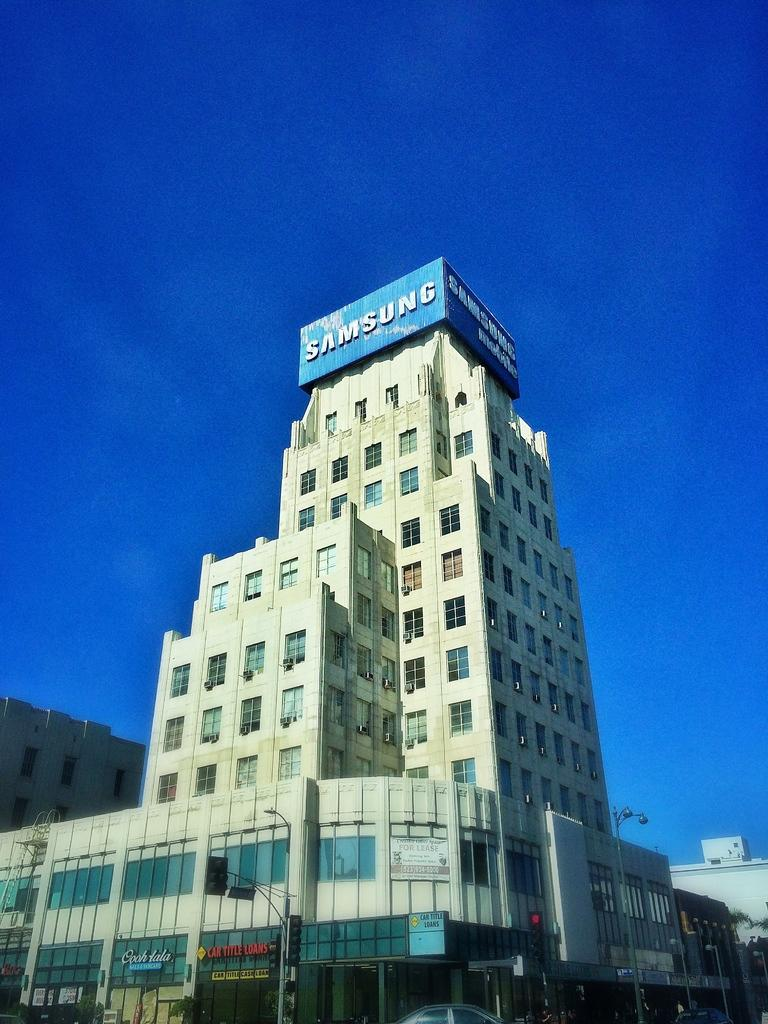What type of structures can be seen in the image? There are buildings in the image. What are some other objects present in the image? Street poles, street lights, traffic poles, traffic signals, and name boards are visible in the image. What mode of transportation can be seen on the road? Motor vehicles are on the road in the image. What natural elements are present in the image? Trees are visible in the image. What part of the environment is visible in the image? The sky is visible in the image. What year is written on the notebook in the image? There is no notebook present in the image. How many balls are visible in the image? There are no balls present in the image. 